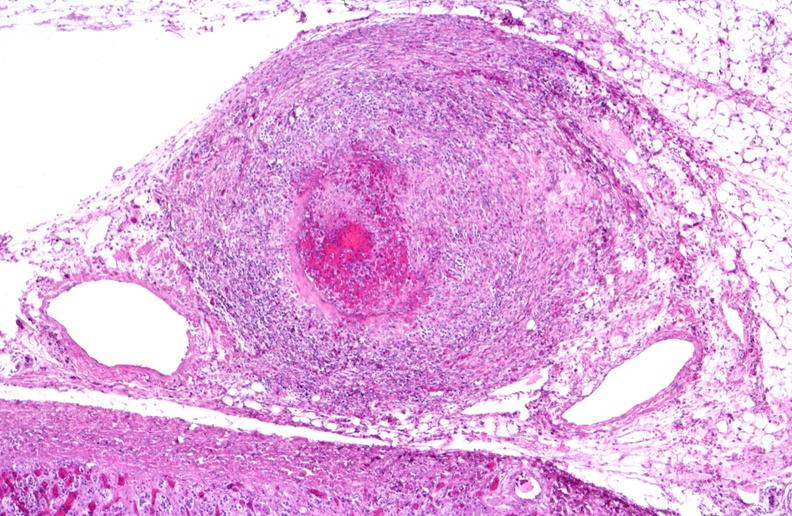what is present?
Answer the question using a single word or phrase. Vasculature 